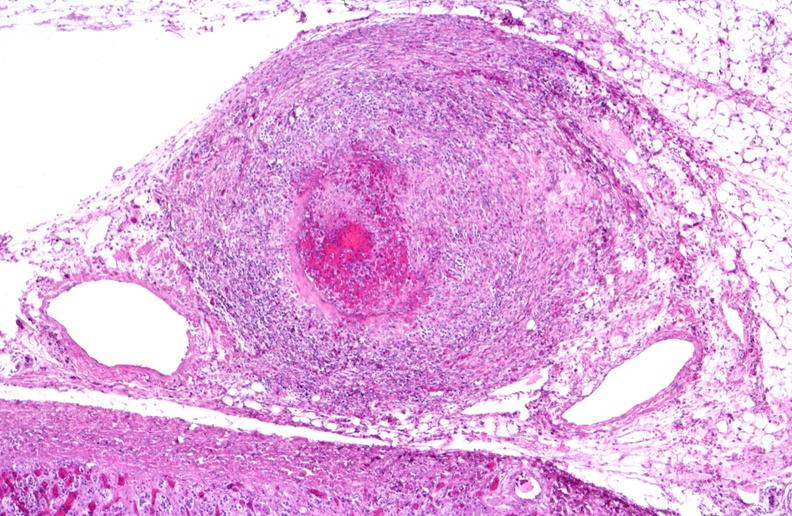what is present?
Answer the question using a single word or phrase. Vasculature 